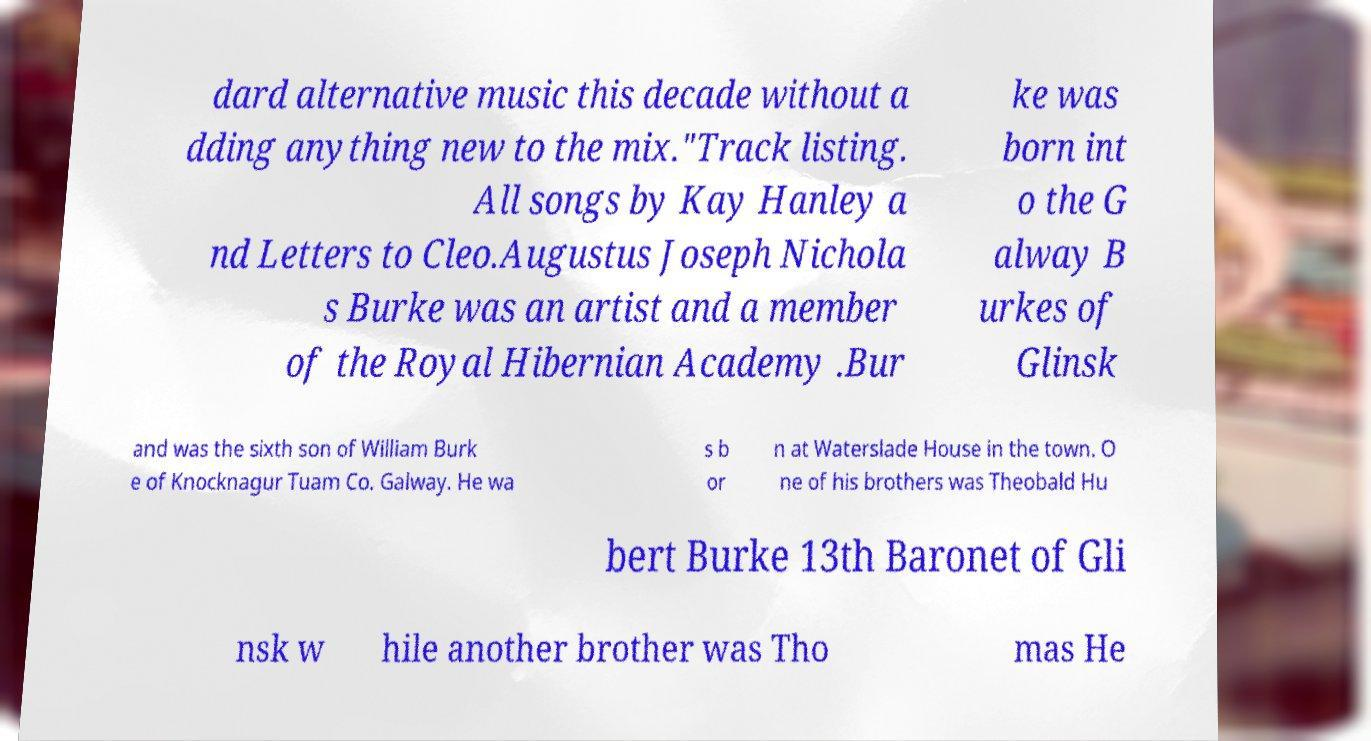Please read and relay the text visible in this image. What does it say? dard alternative music this decade without a dding anything new to the mix."Track listing. All songs by Kay Hanley a nd Letters to Cleo.Augustus Joseph Nichola s Burke was an artist and a member of the Royal Hibernian Academy .Bur ke was born int o the G alway B urkes of Glinsk and was the sixth son of William Burk e of Knocknagur Tuam Co. Galway. He wa s b or n at Waterslade House in the town. O ne of his brothers was Theobald Hu bert Burke 13th Baronet of Gli nsk w hile another brother was Tho mas He 